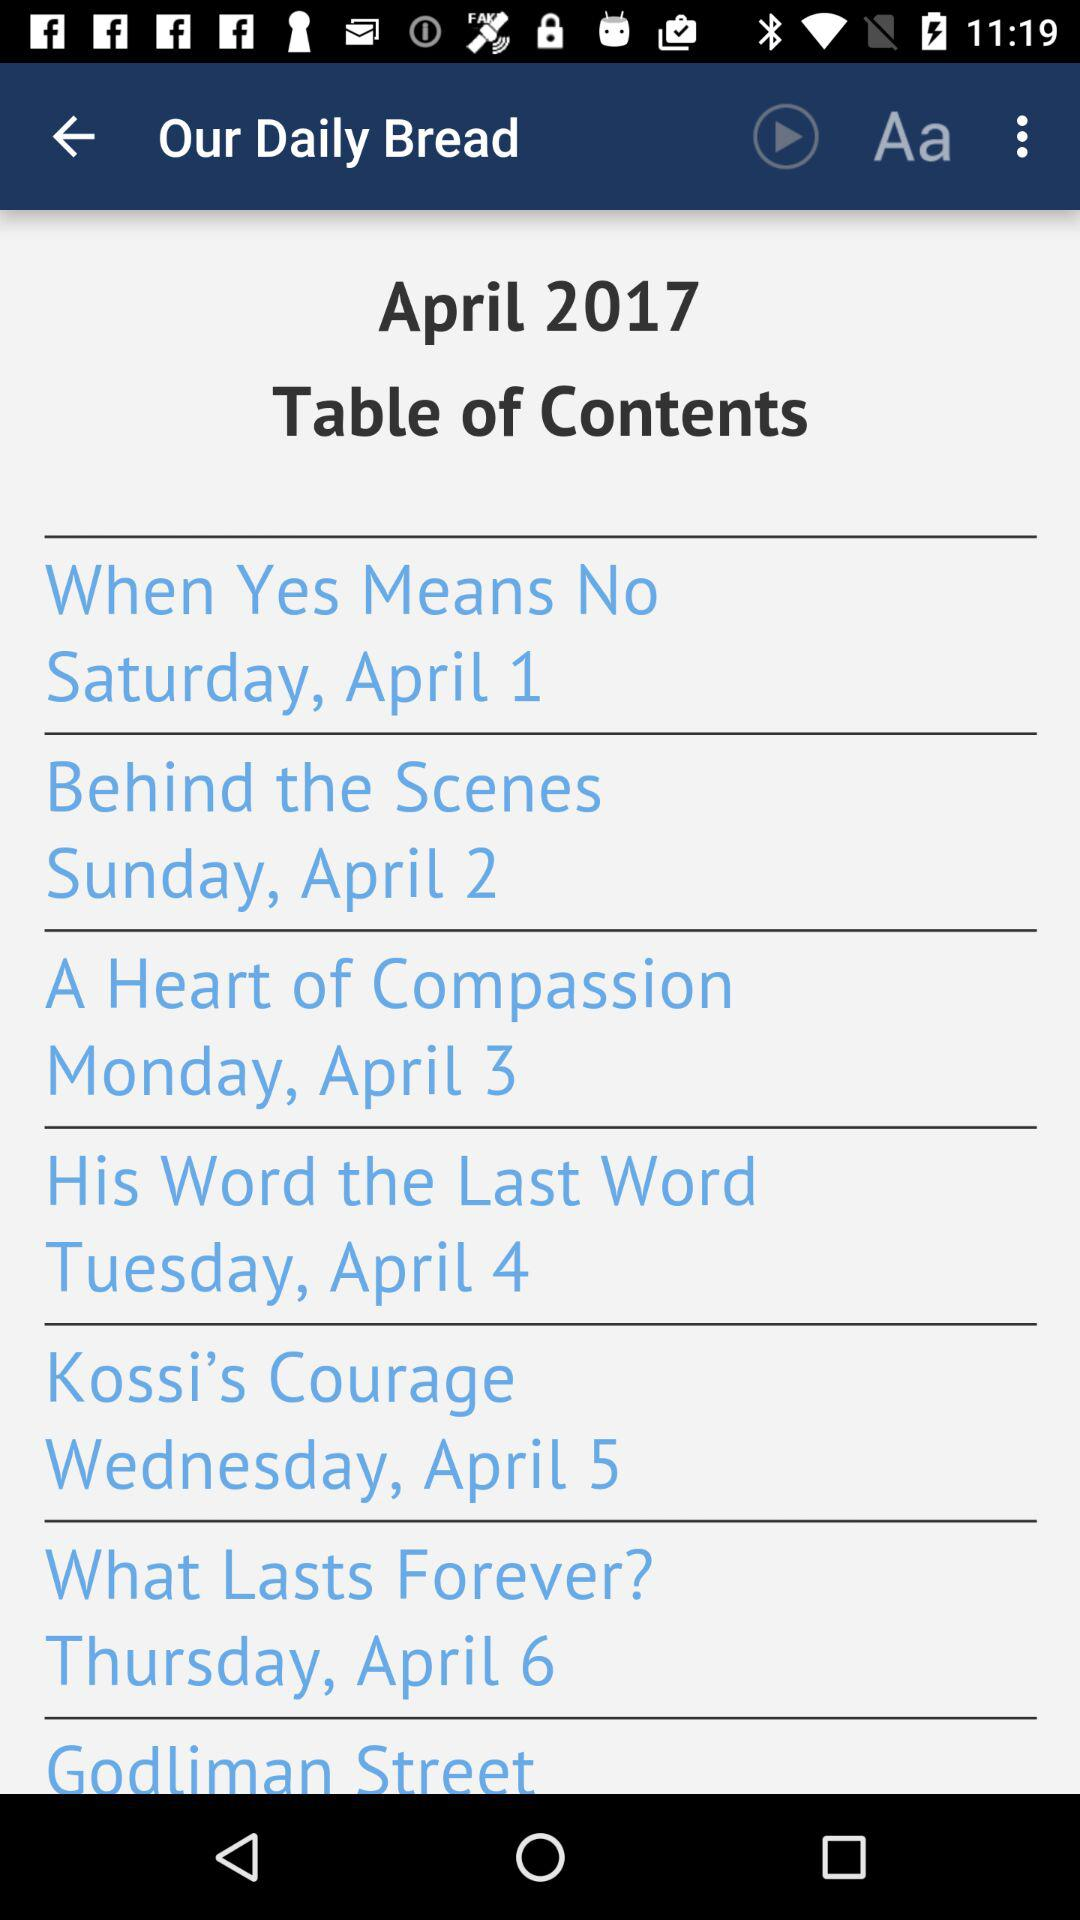On which date was the article "What Lasts Forever?" posted? The article was posted on Thursday, April 6, 2017. 